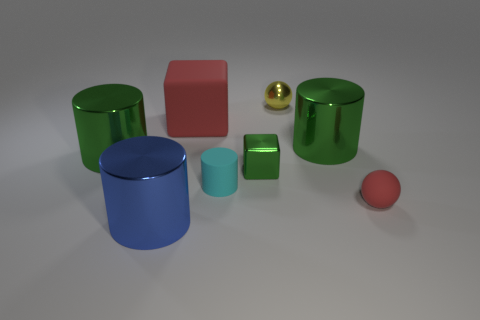Are there any purple matte things of the same shape as the big blue object?
Your answer should be very brief. No. What is the small cylinder made of?
Make the answer very short. Rubber. There is a shiny cube; are there any shiny cubes behind it?
Your response must be concise. No. There is a tiny matte thing on the left side of the tiny green metal object; how many large green cylinders are on the left side of it?
Your answer should be very brief. 1. There is a red block that is the same size as the blue thing; what is its material?
Provide a short and direct response. Rubber. What number of other things are there of the same material as the small cylinder
Keep it short and to the point. 2. What number of tiny objects are in front of the tiny cyan matte thing?
Your answer should be very brief. 1. How many blocks are either small gray metallic things or big blue shiny things?
Your answer should be compact. 0. What size is the metallic cylinder that is left of the small green cube and behind the green metal block?
Your answer should be very brief. Large. What number of other things are there of the same color as the large rubber object?
Keep it short and to the point. 1. 